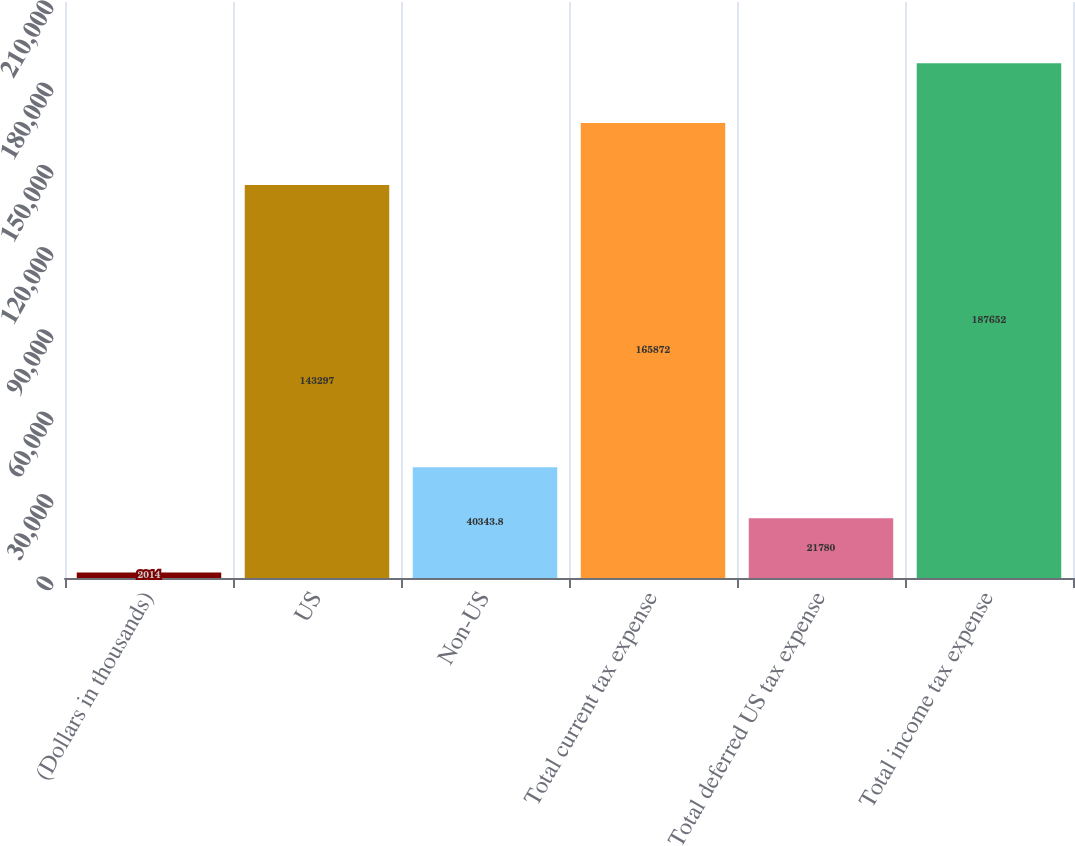Convert chart. <chart><loc_0><loc_0><loc_500><loc_500><bar_chart><fcel>(Dollars in thousands)<fcel>US<fcel>Non-US<fcel>Total current tax expense<fcel>Total deferred US tax expense<fcel>Total income tax expense<nl><fcel>2014<fcel>143297<fcel>40343.8<fcel>165872<fcel>21780<fcel>187652<nl></chart> 